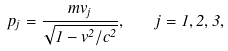Convert formula to latex. <formula><loc_0><loc_0><loc_500><loc_500>p _ { j } = \frac { m v _ { j } } { \sqrt { 1 - v ^ { 2 } / c ^ { 2 } } } , \quad j = 1 , 2 , 3 ,</formula> 